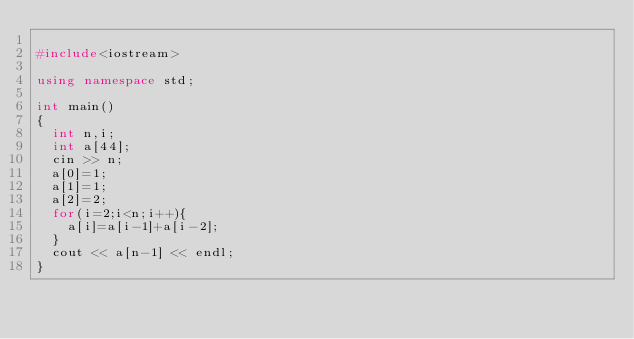<code> <loc_0><loc_0><loc_500><loc_500><_C++_>
#include<iostream>

using namespace std;

int main()
{
	int n,i;
	int a[44];
	cin >> n;
	a[0]=1;
	a[1]=1;
	a[2]=2;
	for(i=2;i<n;i++){
		a[i]=a[i-1]+a[i-2];
	}
	cout << a[n-1] << endl;
}</code> 